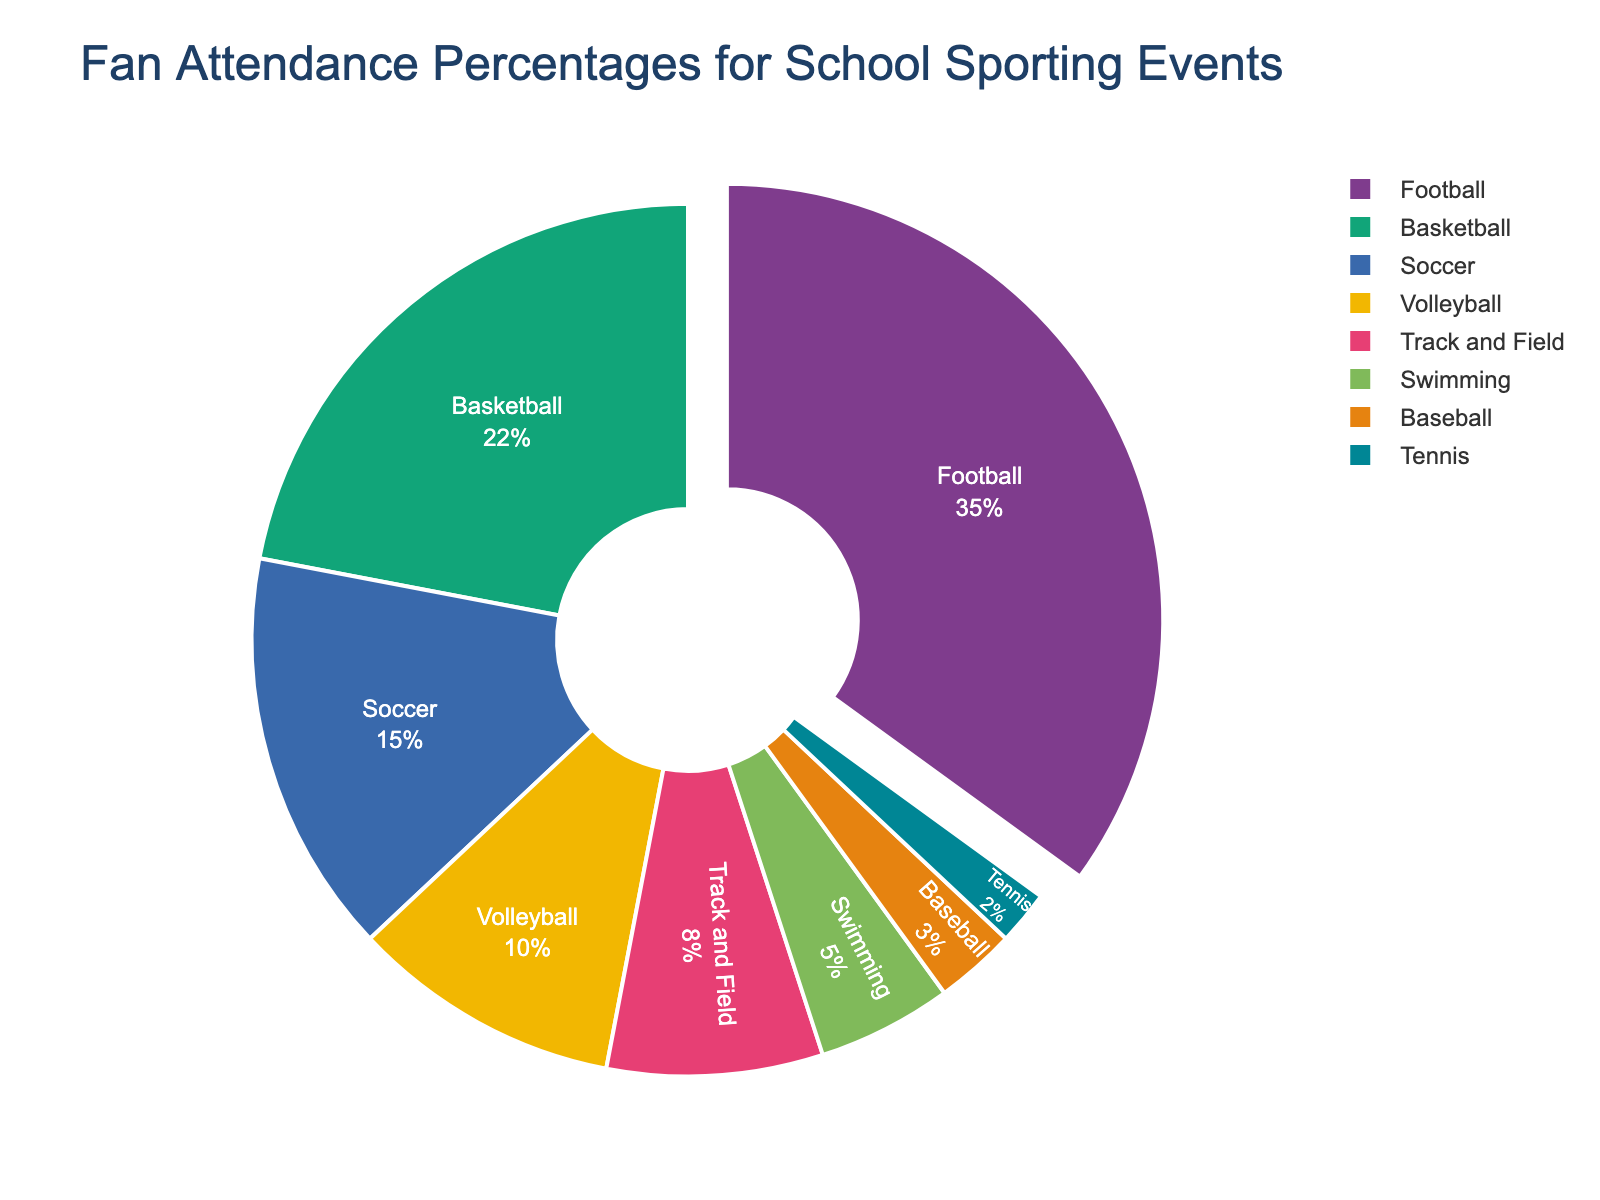Which sport has the highest fan attendance percentage? The largest section of the pie chart corresponds to Football, which takes up 35% of the fan attendance.
Answer: Football Which sports have lower attendance percentages than Volleyball? Volleyball has a fan attendance percentage of 10%. Sports with lower percentages are Track and Field (8%), Swimming (5%), Baseball (3%), and Tennis (2%).
Answer: Track and Field, Swimming, Baseball, Tennis What is the total fan attendance percentage for Soccer and Basketball combined? Soccer has 15% and Basketball has 22%. Adding these percentages gives 15 + 22 = 37%.
Answer: 37% How much higher is the attendance percentage for Football compared to Soccer? Football has 35% fan attendance, while Soccer has 15%. The difference is 35 - 15 = 20%.
Answer: 20% What color represents the sport with the least fan attendance percentage? Tennis, which has the least fan attendance percentage (2%), is visually represented in a particular color.
Answer: (Filename required for exact color, may be specified in the code, or else interpretation required) What is the combined attendance percentage for all sports except for Football? The total for all sports is 100%. Subtracting the percentage for Football (35%) gives 100 - 35 = 65%.
Answer: 65% Compare the fan attendance percentages for Basketball and Track and Field. Which one is higher and by how much? Basketball has 22%, while Track and Field has 8%. Basketball has a higher attendance by 22 - 8 = 14%.
Answer: Basketball by 14% What fraction of the total fan attendance does Swimming and Baseball together account for? Swimming has 5% and Baseball has 3%. Combined, they account for 5 + 3 = 8%. The fraction is 8/100 = 2/25.
Answer: 2/25 If the sum of fan attendance percentages for Football and Basketball is split evenly between the two, what would be the new percentage for each sport? The sum of Football (35%) and Basketball (22%) is 35 + 22 = 57%. Split evenly, each sport would get 57/2 = 28.5%.
Answer: 28.5% What is the visual difference for the sport that has a section pulled out of the pie chart? The sport with a section pulled out is Football. This is visually represented by a noticeable gap between Football's section and the rest of the pie chart.
Answer: Football's section is pulled out 